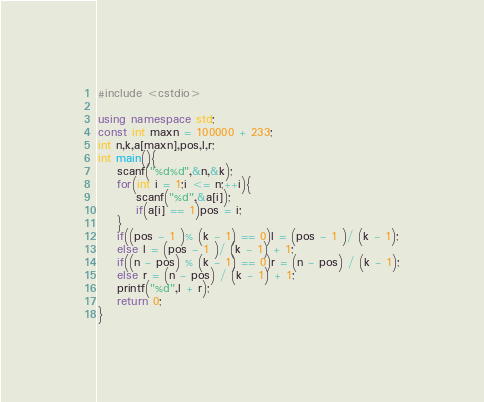Convert code to text. <code><loc_0><loc_0><loc_500><loc_500><_C++_>#include <cstdio>

using namespace std;
const int maxn = 100000 + 233;
int n,k,a[maxn],pos,l,r;
int main(){
	scanf("%d%d",&n,&k);
	for(int i = 1;i <= n;++i){
		scanf("%d",&a[i]);
		if(a[i] == 1)pos = i;
	}
	if((pos - 1 )% (k - 1) == 0)l = (pos - 1 )/ (k - 1);
	else l = (pos - 1 )/ (k - 1) + 1;
	if((n - pos) % (k - 1) == 0)r = (n - pos) / (k - 1);
	else r = (n - pos) / (k - 1) + 1;
	printf("%d",l + r);
	return 0;
}</code> 